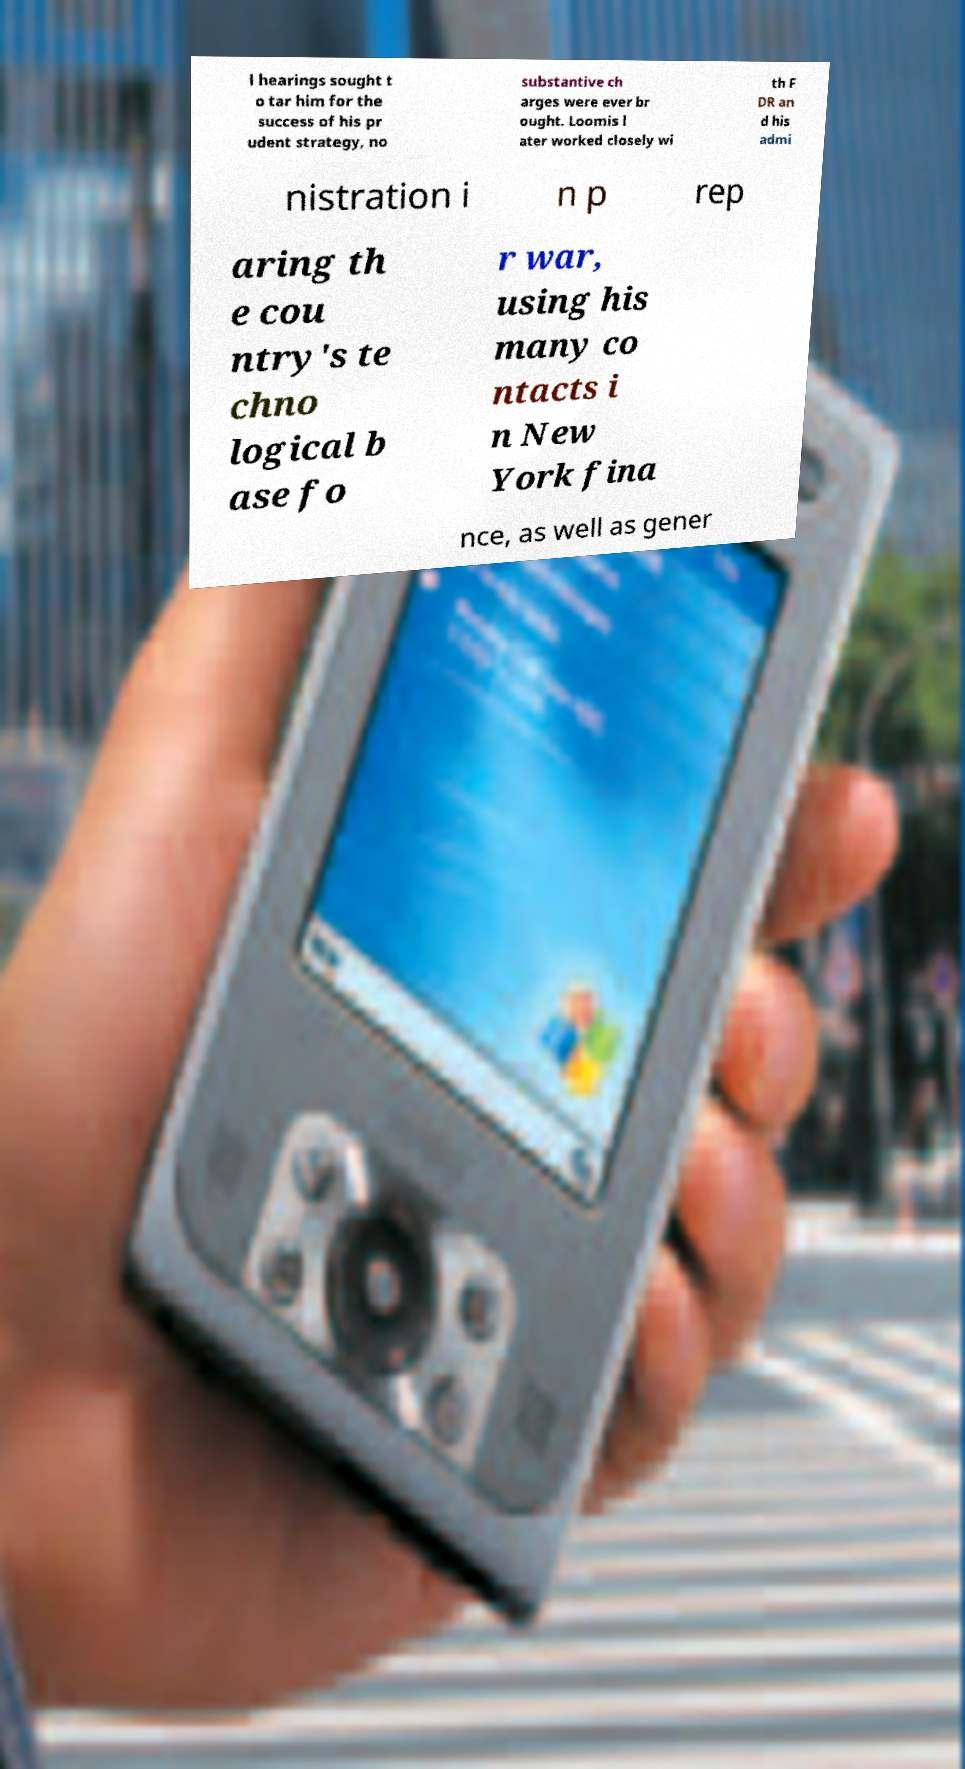There's text embedded in this image that I need extracted. Can you transcribe it verbatim? l hearings sought t o tar him for the success of his pr udent strategy, no substantive ch arges were ever br ought. Loomis l ater worked closely wi th F DR an d his admi nistration i n p rep aring th e cou ntry's te chno logical b ase fo r war, using his many co ntacts i n New York fina nce, as well as gener 